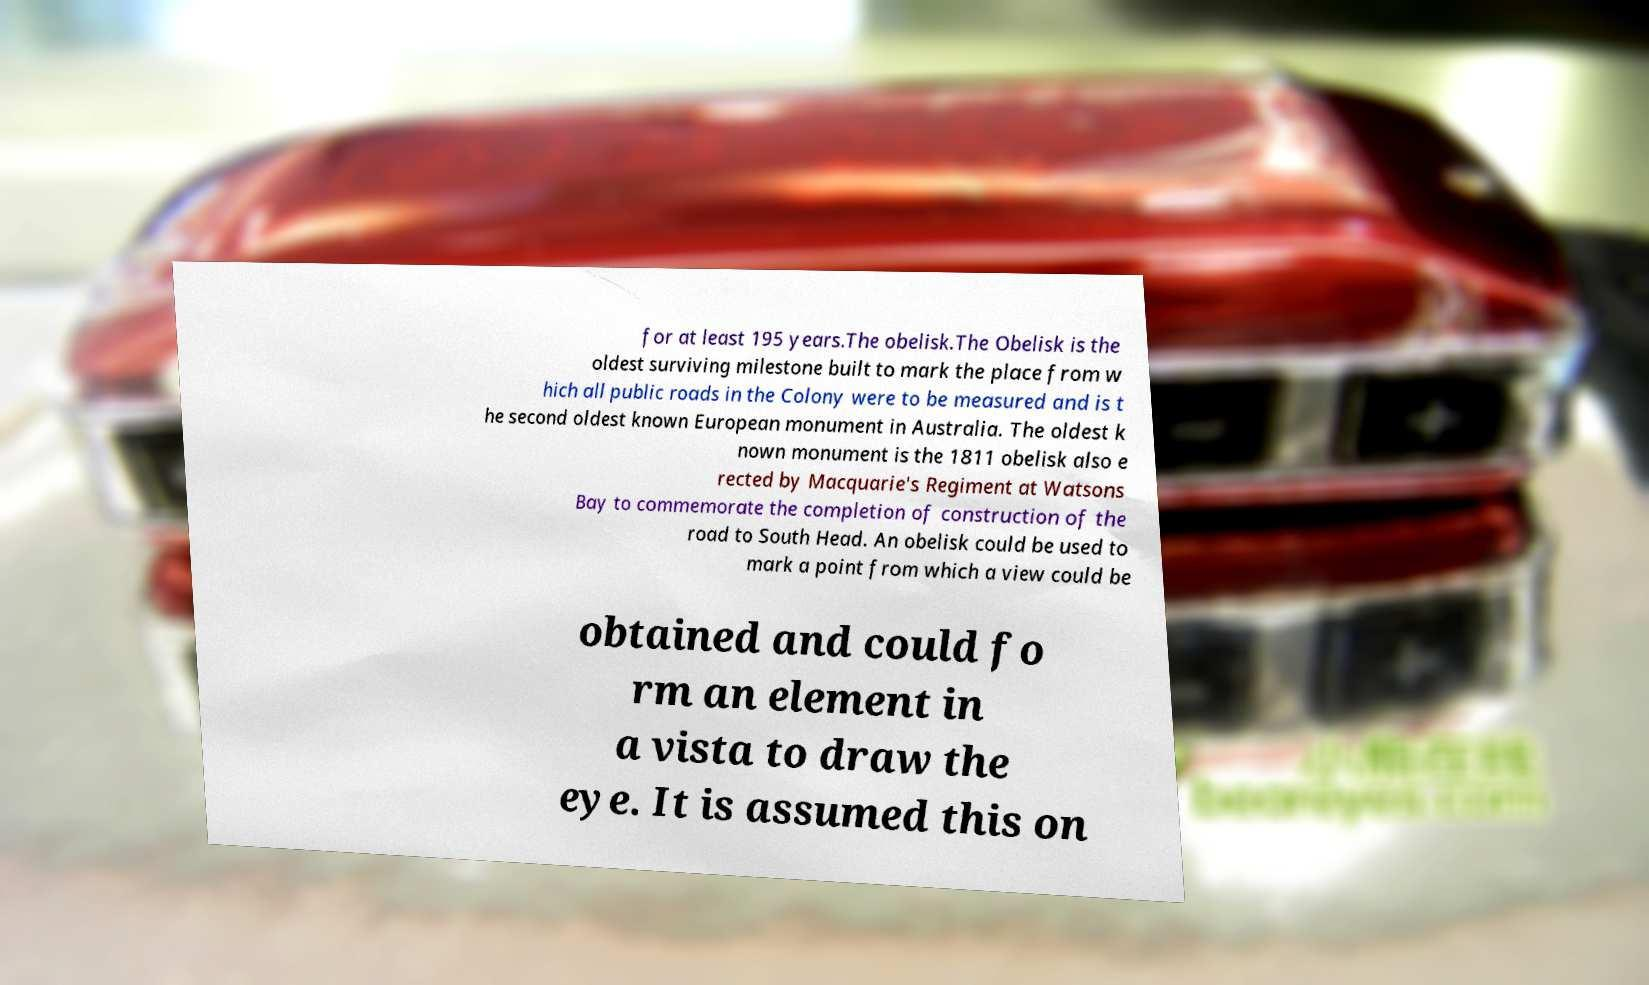Please read and relay the text visible in this image. What does it say? for at least 195 years.The obelisk.The Obelisk is the oldest surviving milestone built to mark the place from w hich all public roads in the Colony were to be measured and is t he second oldest known European monument in Australia. The oldest k nown monument is the 1811 obelisk also e rected by Macquarie's Regiment at Watsons Bay to commemorate the completion of construction of the road to South Head. An obelisk could be used to mark a point from which a view could be obtained and could fo rm an element in a vista to draw the eye. It is assumed this on 